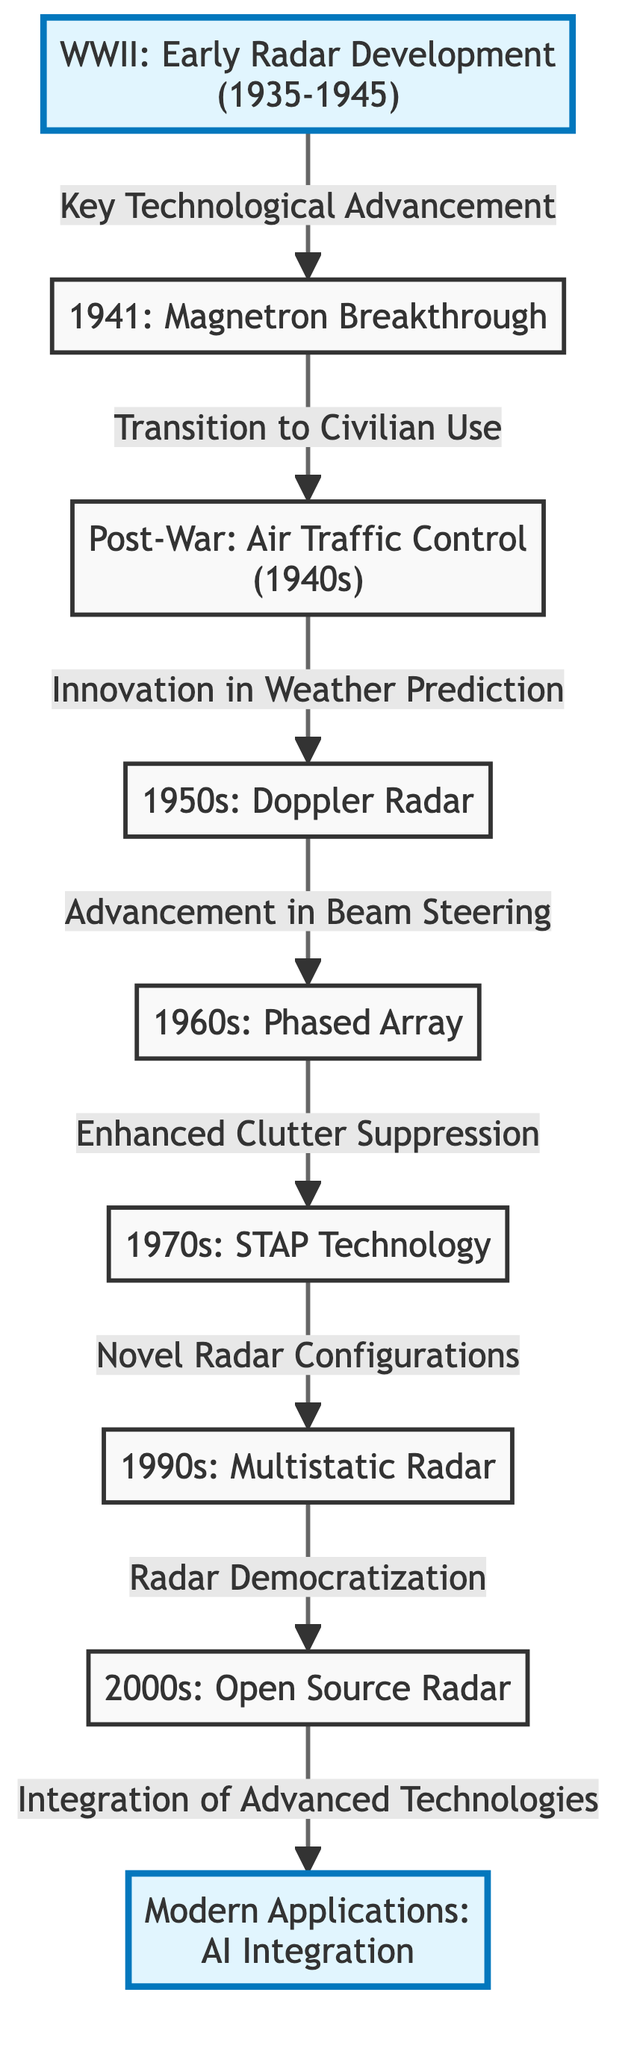What milestone marks the beginning of radar technology development? The diagram indicates that WWII marks the early radar development from 1935 to 1945, which is the foundational milestone for radar technology.
Answer: WWII: Early Radar Development (1935-1945) What key technology breakthrough occurred in 1941? According to the diagram, the key technological advancement in 1941 was the Magnetron breakthrough, highlighting a significant development in radar technology.
Answer: Magnetron Breakthrough Which technology was introduced in the 1950s? The diagram shows that the 1950s saw the introduction of Doppler Radar, signifying an important advancement in radar capabilities.
Answer: Doppler Radar How many major milestones are illustrated in the diagram? By counting the distinct milestone nodes, we can see that there are four major milestones: WWII, AI, Magnetron, and Open Source Radar, indicating key progressions in radar technology development.
Answer: 4 What was the relationship between Air Control and Doppler technology? The diagram illustrates that Air Control, which transitioned to civilian use in the 1940s, was innovatively linked to weather prediction, thus leading to the development of Doppler technology in the 1950s.
Answer: Innovation in Weather Prediction What did the Phased Array enhance compared to previous technologies? The diagram states that Phased Array technology, introduced in the 1960s, enhanced beam steering capabilities, showing its advancement over earlier radar technologies.
Answer: Advancement in Beam Steering What technological advancement followed the Multistatic Radar in the timeline? The flowchart shows that Open Source Radar technology followed Multistatic Radar, indicating an evolution in radar development occurred in the 2000s.
Answer: Open Source Radar What does the final milestone in the diagram represent? The last milestone in the timeline is modern applications specifically focusing on AI integration, which indicates the latest phase in the evolution of radar technology.
Answer: AI Integration What does the transition from Multistatic Radar lead to in terms of community use? The diagram mentions that the transition to Open Source Radar from Multistatic Radar symbolizes the democratization of radar technology, reflecting a broader accessibility of these technologies.
Answer: Radar Democratization 